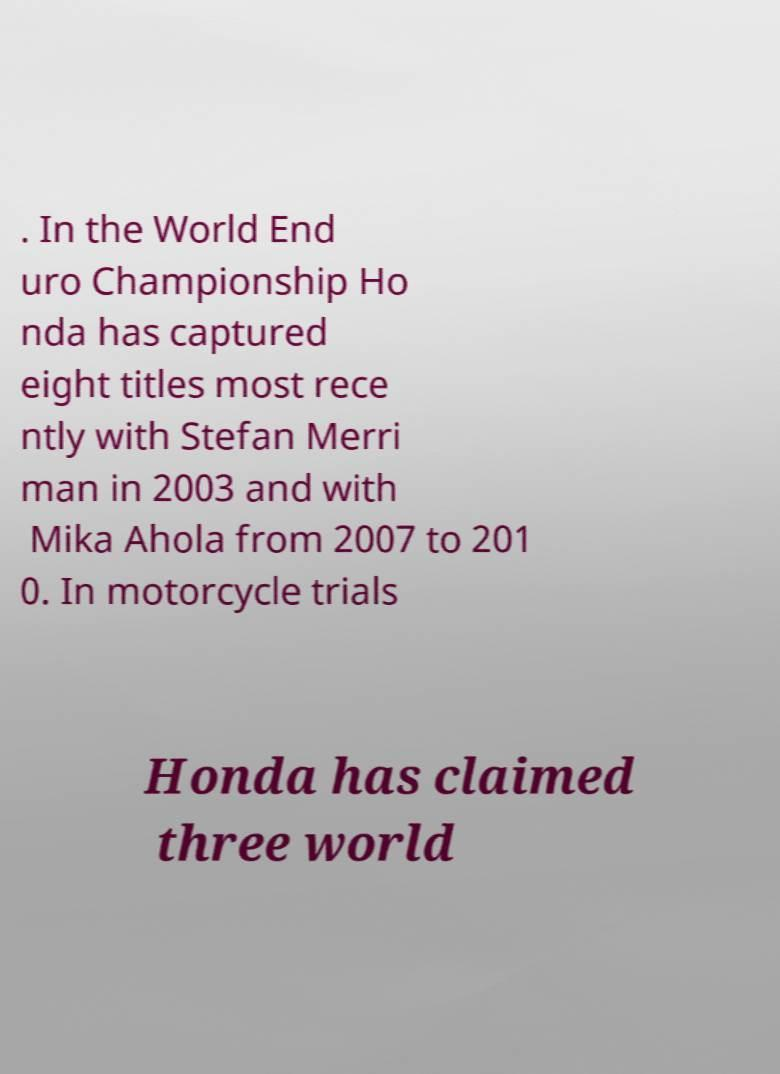Can you read and provide the text displayed in the image?This photo seems to have some interesting text. Can you extract and type it out for me? . In the World End uro Championship Ho nda has captured eight titles most rece ntly with Stefan Merri man in 2003 and with Mika Ahola from 2007 to 201 0. In motorcycle trials Honda has claimed three world 